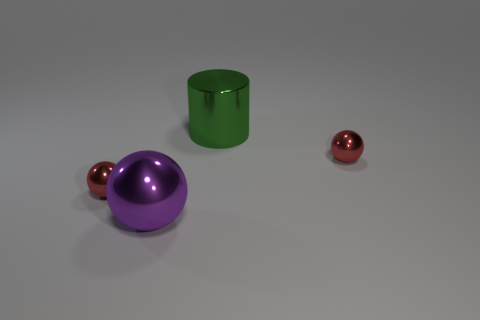Can you describe the lighting of this scene? The scene is evenly lit with soft shadows, indicating diffuse lighting, which avoids harsh shadows and highlights, giving it a calm, neutral atmosphere. 